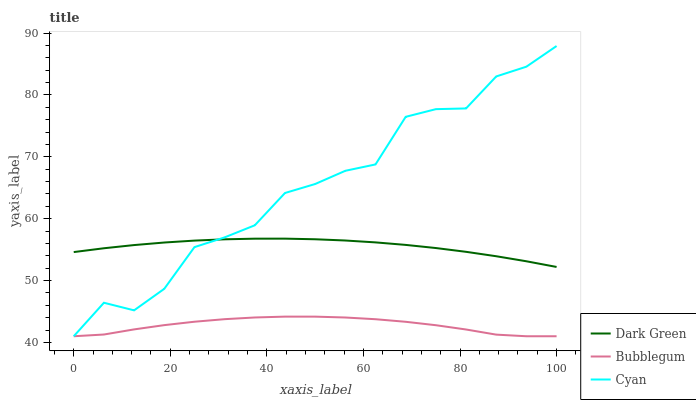Does Bubblegum have the minimum area under the curve?
Answer yes or no. Yes. Does Cyan have the maximum area under the curve?
Answer yes or no. Yes. Does Dark Green have the minimum area under the curve?
Answer yes or no. No. Does Dark Green have the maximum area under the curve?
Answer yes or no. No. Is Dark Green the smoothest?
Answer yes or no. Yes. Is Cyan the roughest?
Answer yes or no. Yes. Is Bubblegum the smoothest?
Answer yes or no. No. Is Bubblegum the roughest?
Answer yes or no. No. Does Cyan have the lowest value?
Answer yes or no. Yes. Does Dark Green have the lowest value?
Answer yes or no. No. Does Cyan have the highest value?
Answer yes or no. Yes. Does Dark Green have the highest value?
Answer yes or no. No. Is Bubblegum less than Dark Green?
Answer yes or no. Yes. Is Dark Green greater than Bubblegum?
Answer yes or no. Yes. Does Bubblegum intersect Cyan?
Answer yes or no. Yes. Is Bubblegum less than Cyan?
Answer yes or no. No. Is Bubblegum greater than Cyan?
Answer yes or no. No. Does Bubblegum intersect Dark Green?
Answer yes or no. No. 